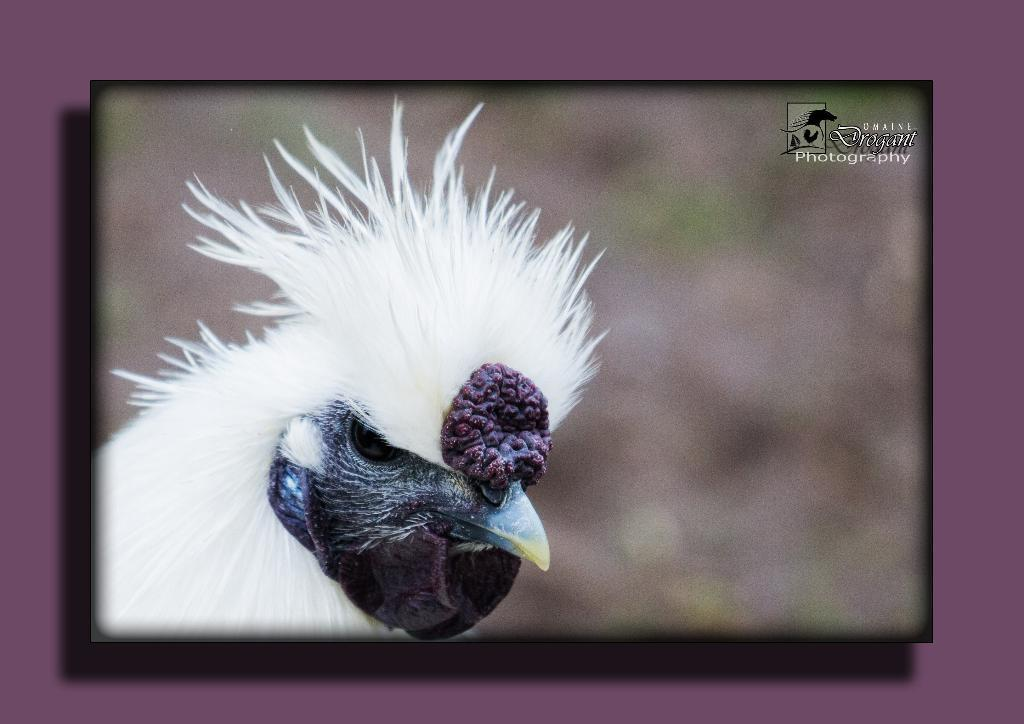What type of animal is in the image? There is a bird in the image. What color is the bird? The bird is white. Where is the bird located in the image? The bird is on the left side of the image. What can be seen on the right top of the image? There is text on the right top of the image. How would you describe the background of the image? The background of the image is blurred. How many tubs are visible in the image? There are no tubs present in the image. What is the bird's wealth status in the image? The bird's wealth status cannot be determined from the image, as birds do not have wealth. 